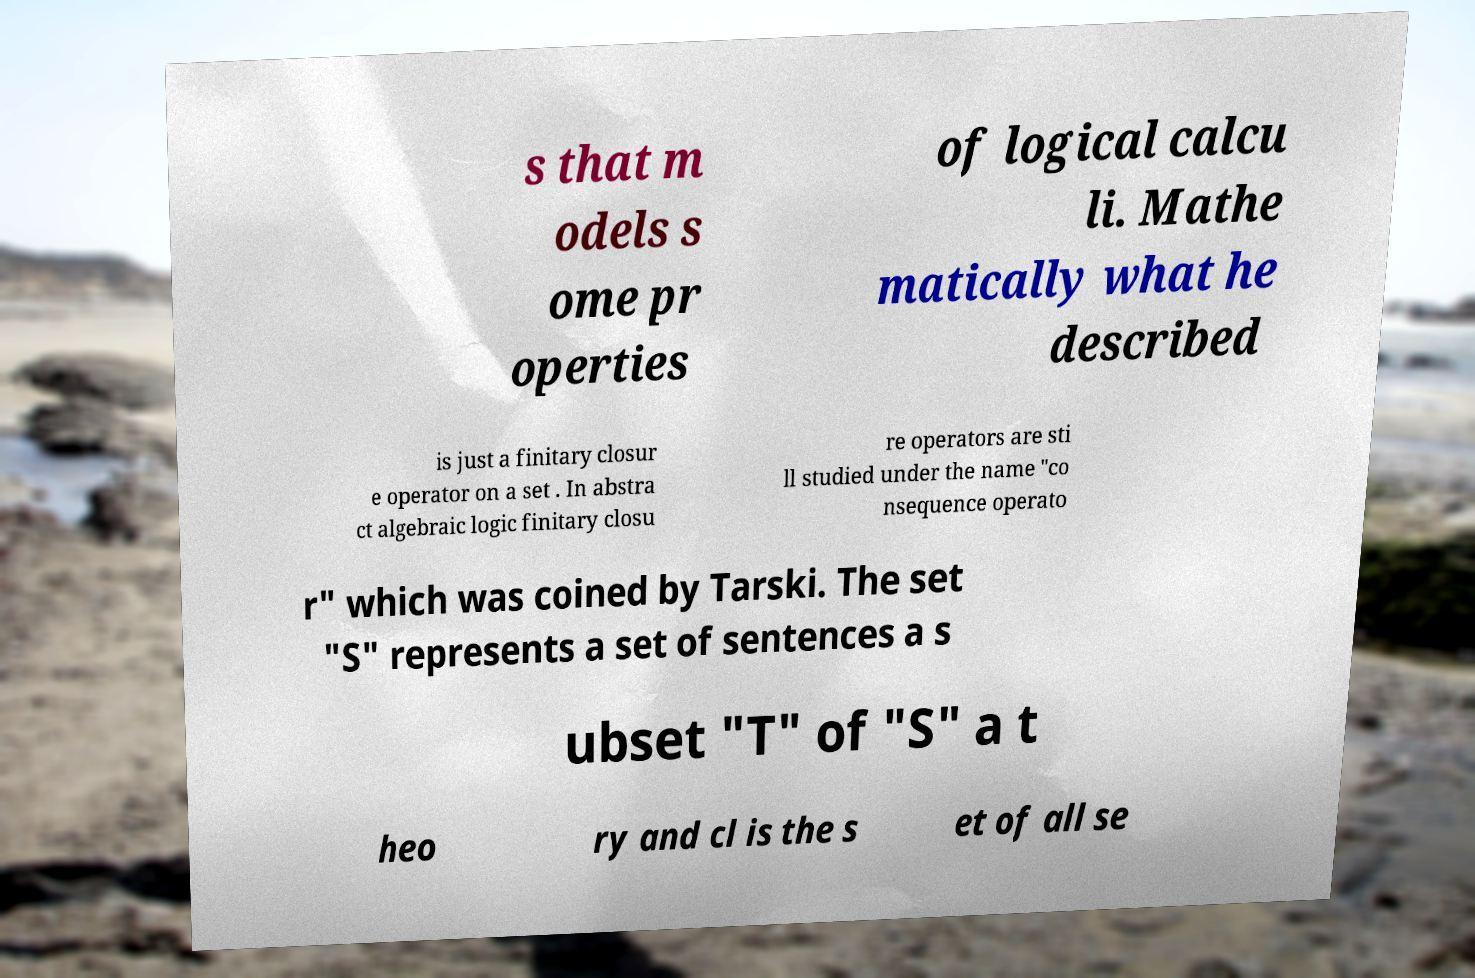Could you assist in decoding the text presented in this image and type it out clearly? s that m odels s ome pr operties of logical calcu li. Mathe matically what he described is just a finitary closur e operator on a set . In abstra ct algebraic logic finitary closu re operators are sti ll studied under the name "co nsequence operato r" which was coined by Tarski. The set "S" represents a set of sentences a s ubset "T" of "S" a t heo ry and cl is the s et of all se 